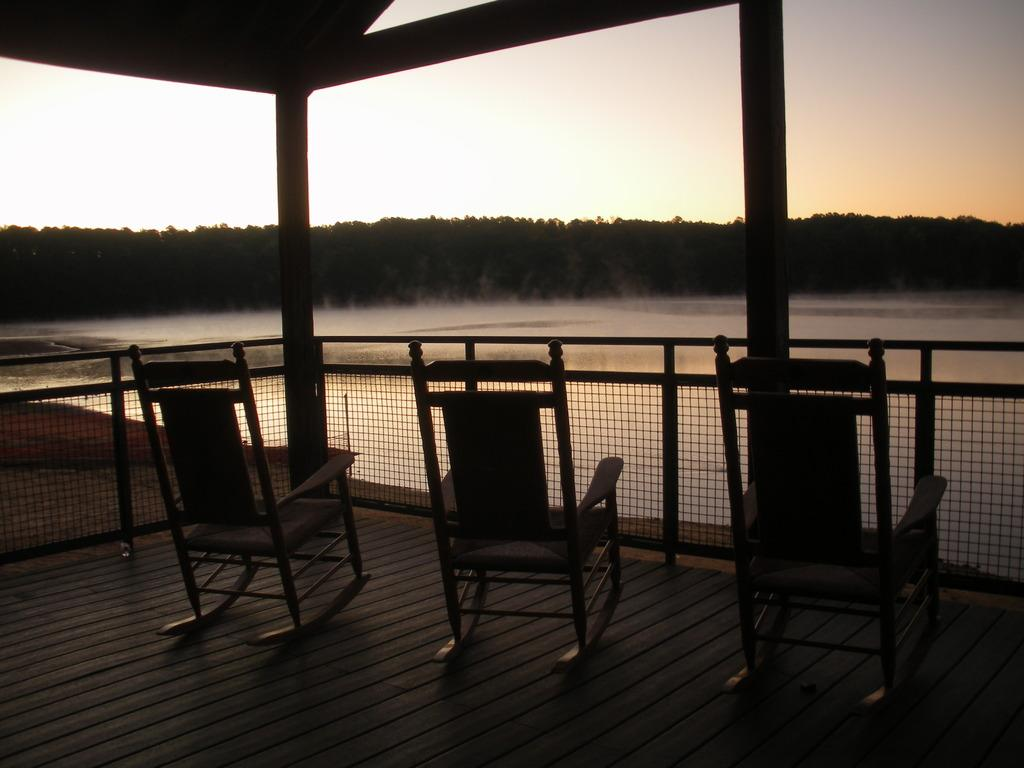What type of furniture can be seen in the image? There are chairs in the image. What type of barrier is present in the image? There is a fence in the image. What architectural feature is visible in the image? There is a roof top with pillars in the image. What natural element can be seen in the image? There is water visible in the image. What type of vegetation is present in the image? There are trees in the image. What is visible in the background of the image? The sky is visible in the background of the image. What type of celery is being used as a rod to hang a board in the image? There is no celery, rod, or board present in the image. 